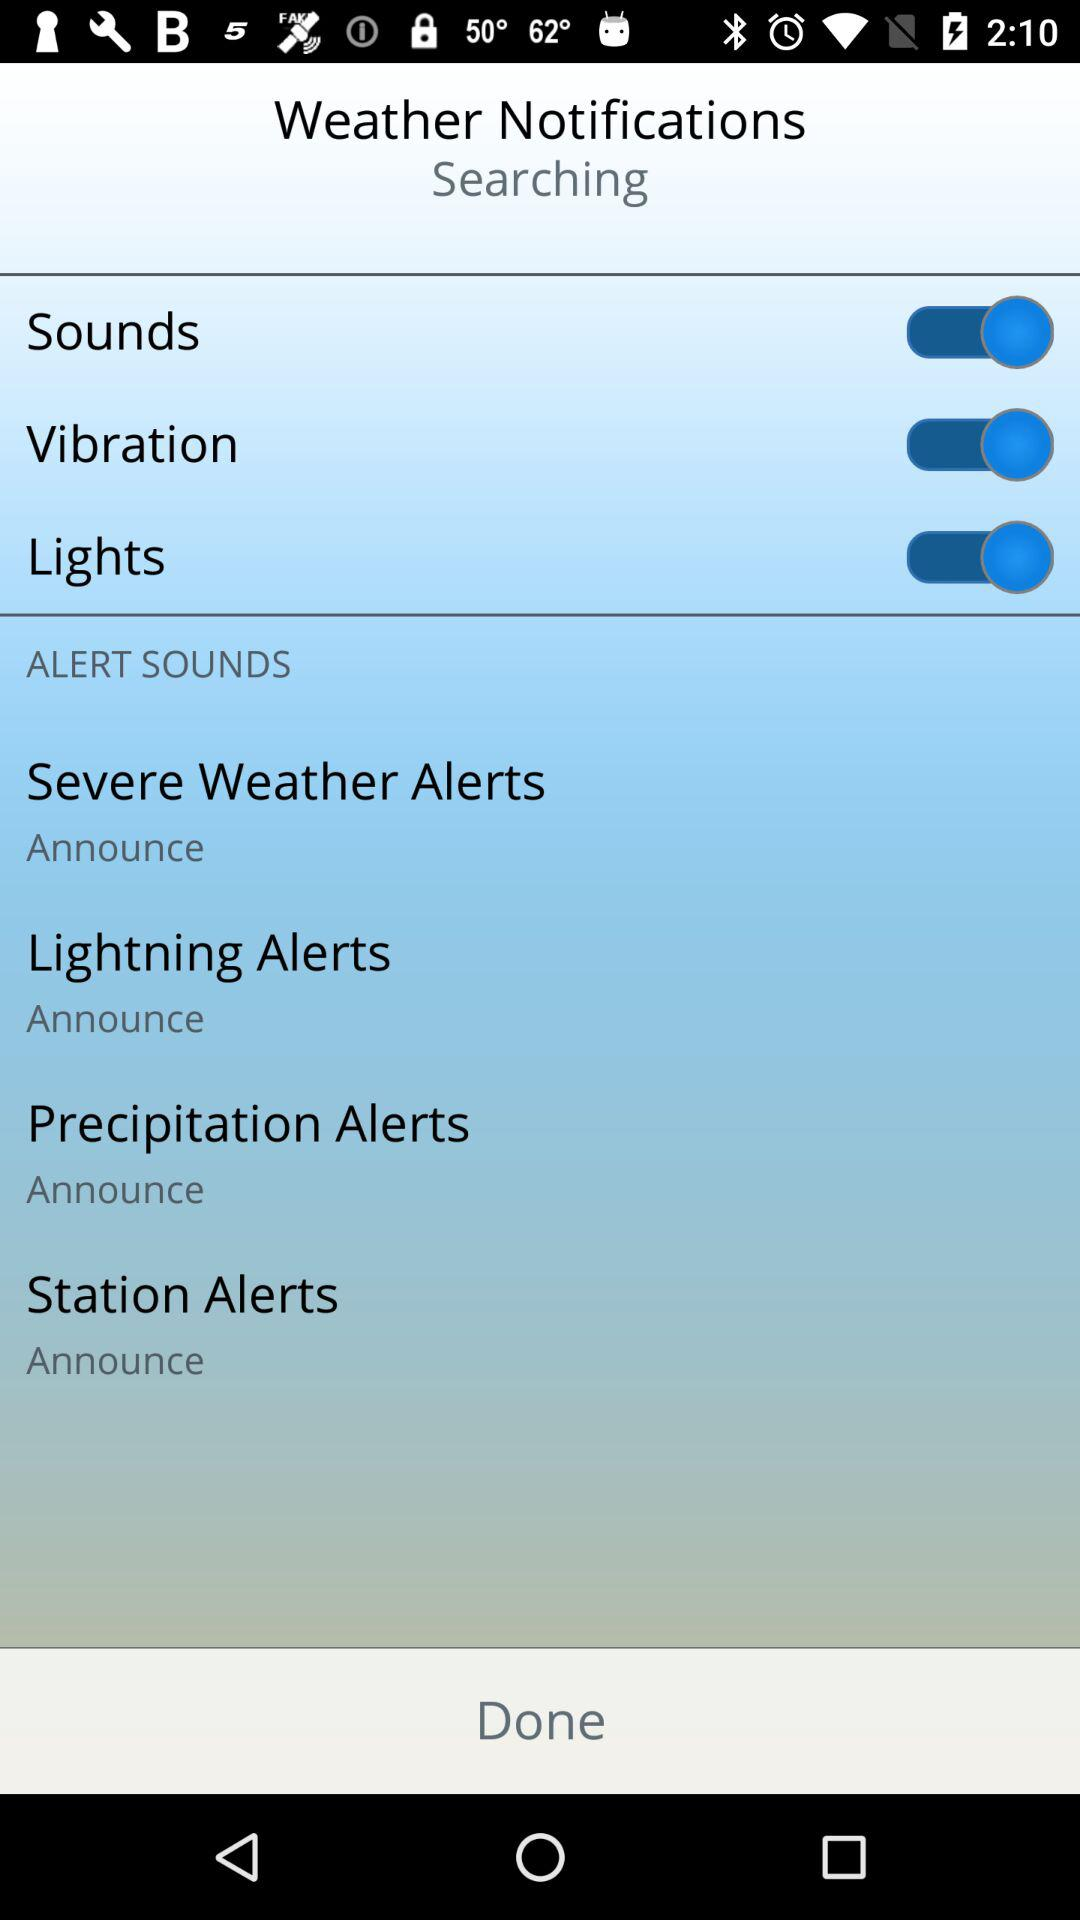What is the current status of the "Lights"? The current status of the "Lights" is "on". 